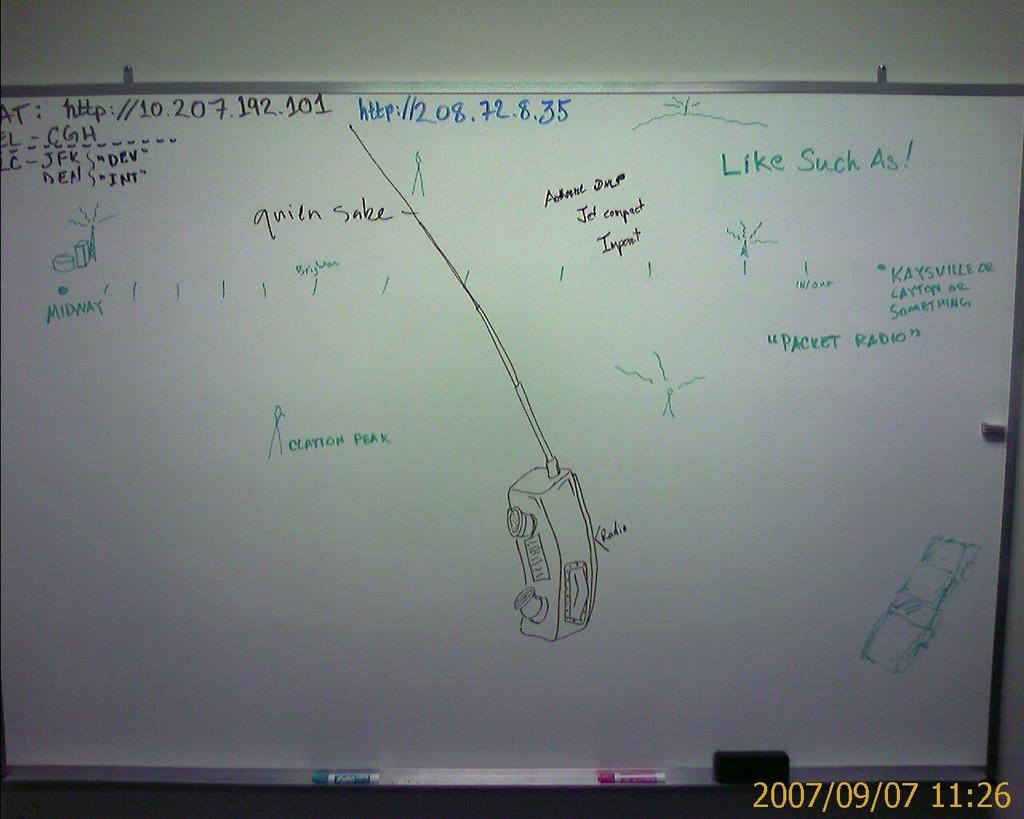What are the numbers written in blue?
Offer a very short reply. 208.72.8.35. The time on the picture is?
Your answer should be compact. 11:26. 